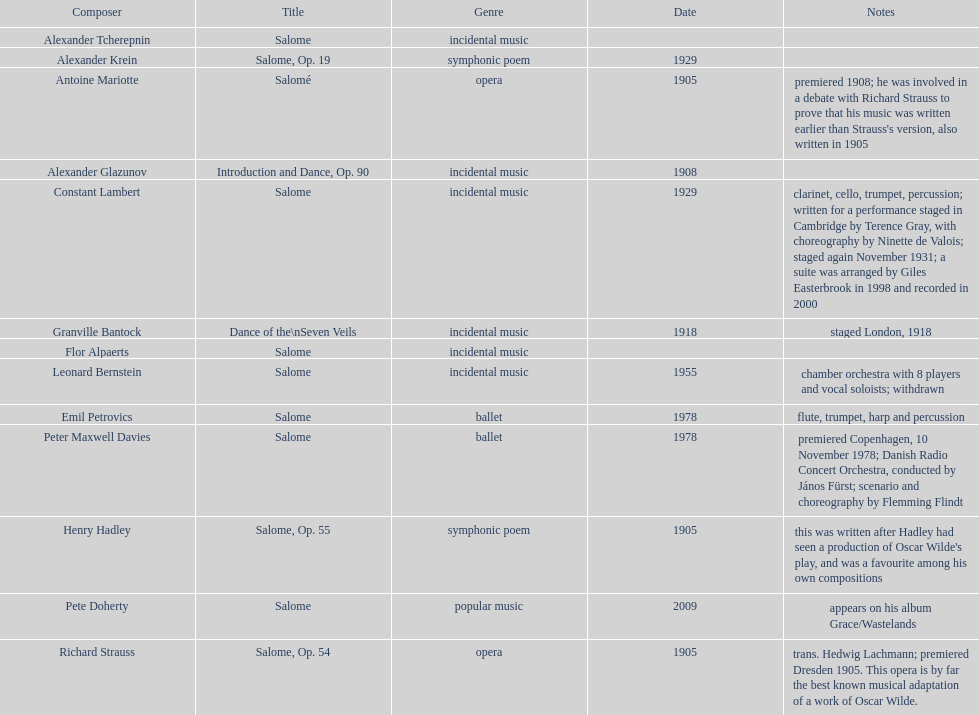Who is on top of the list? Flor Alpaerts. 